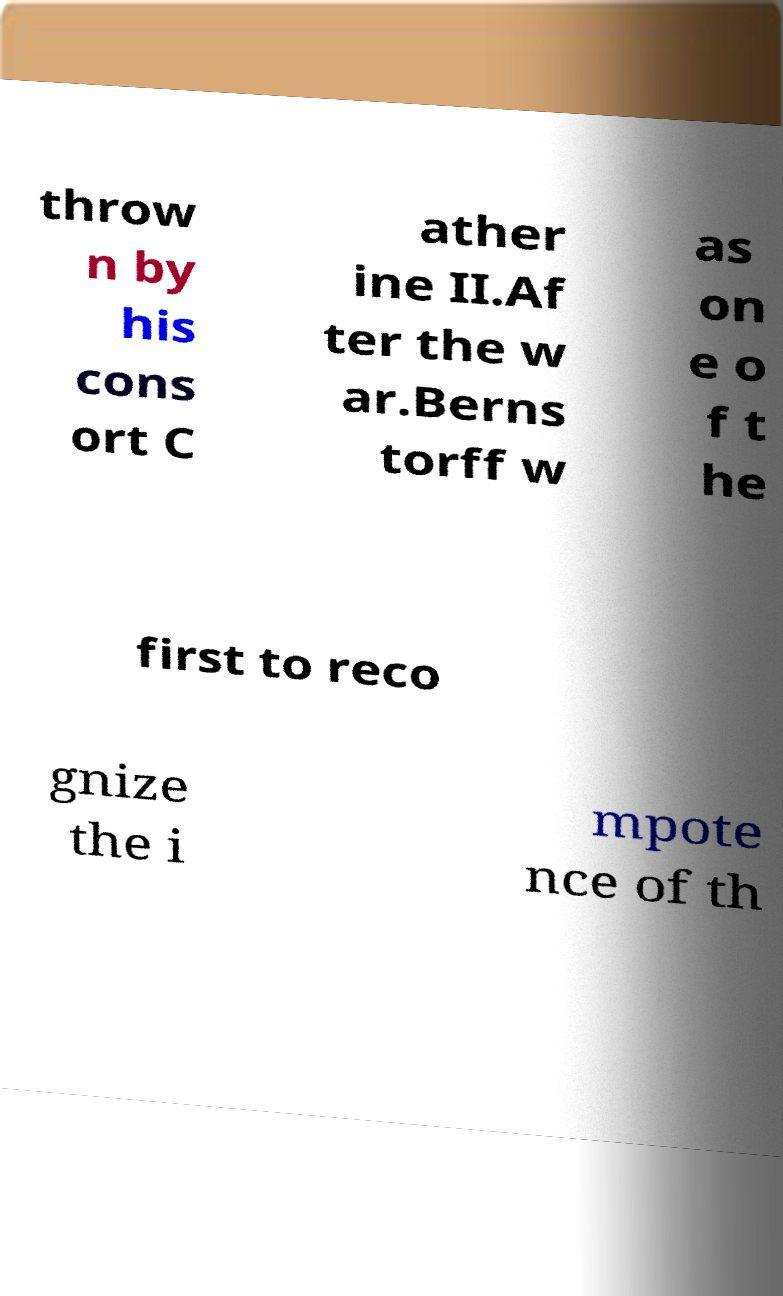What messages or text are displayed in this image? I need them in a readable, typed format. throw n by his cons ort C ather ine II.Af ter the w ar.Berns torff w as on e o f t he first to reco gnize the i mpote nce of th 